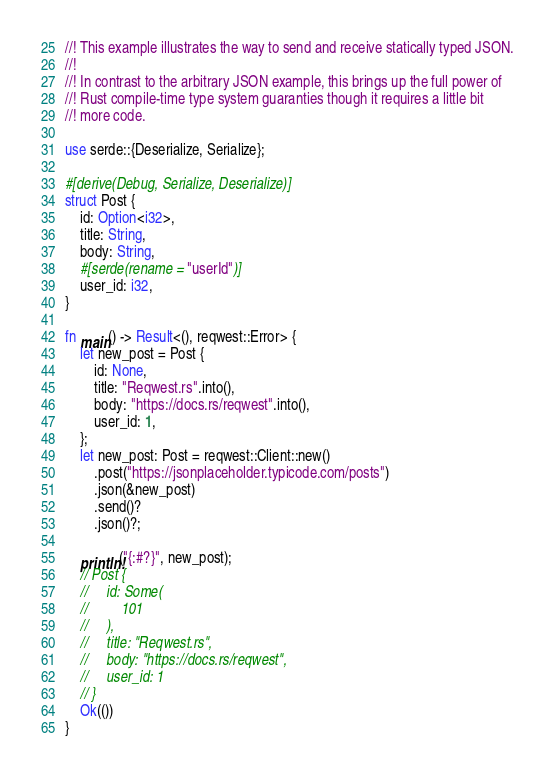<code> <loc_0><loc_0><loc_500><loc_500><_Rust_>//! This example illustrates the way to send and receive statically typed JSON.
//!
//! In contrast to the arbitrary JSON example, this brings up the full power of
//! Rust compile-time type system guaranties though it requires a little bit
//! more code.

use serde::{Deserialize, Serialize};

#[derive(Debug, Serialize, Deserialize)]
struct Post {
    id: Option<i32>,
    title: String,
    body: String,
    #[serde(rename = "userId")]
    user_id: i32,
}

fn main() -> Result<(), reqwest::Error> {
    let new_post = Post {
        id: None,
        title: "Reqwest.rs".into(),
        body: "https://docs.rs/reqwest".into(),
        user_id: 1,
    };
    let new_post: Post = reqwest::Client::new()
        .post("https://jsonplaceholder.typicode.com/posts")
        .json(&new_post)
        .send()?
        .json()?;

    println!("{:#?}", new_post);
    // Post {
    //     id: Some(
    //         101
    //     ),
    //     title: "Reqwest.rs",
    //     body: "https://docs.rs/reqwest",
    //     user_id: 1
    // }
    Ok(())
}
</code> 